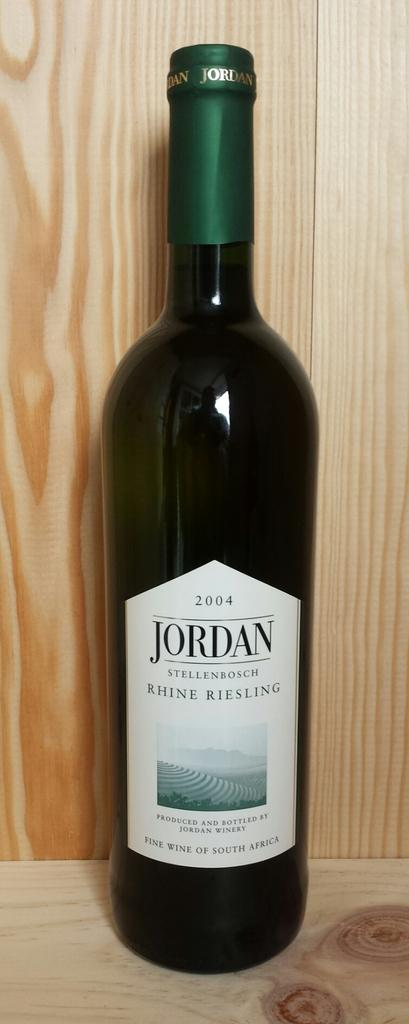<image>
Present a compact description of the photo's key features. A 2004 bottle of wine has a label that says Jordan. 